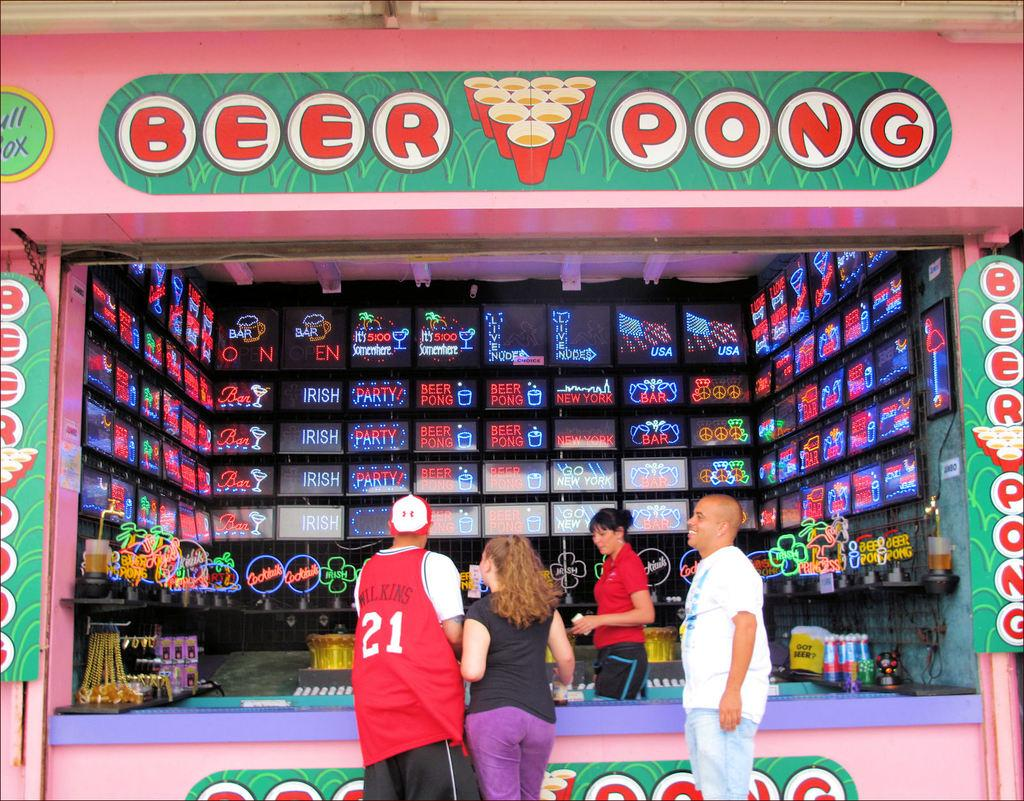Provide a one-sentence caption for the provided image. people playing BEER PONG at a public booth, one of the men has 21 WILKINS on the back of his shirt. 